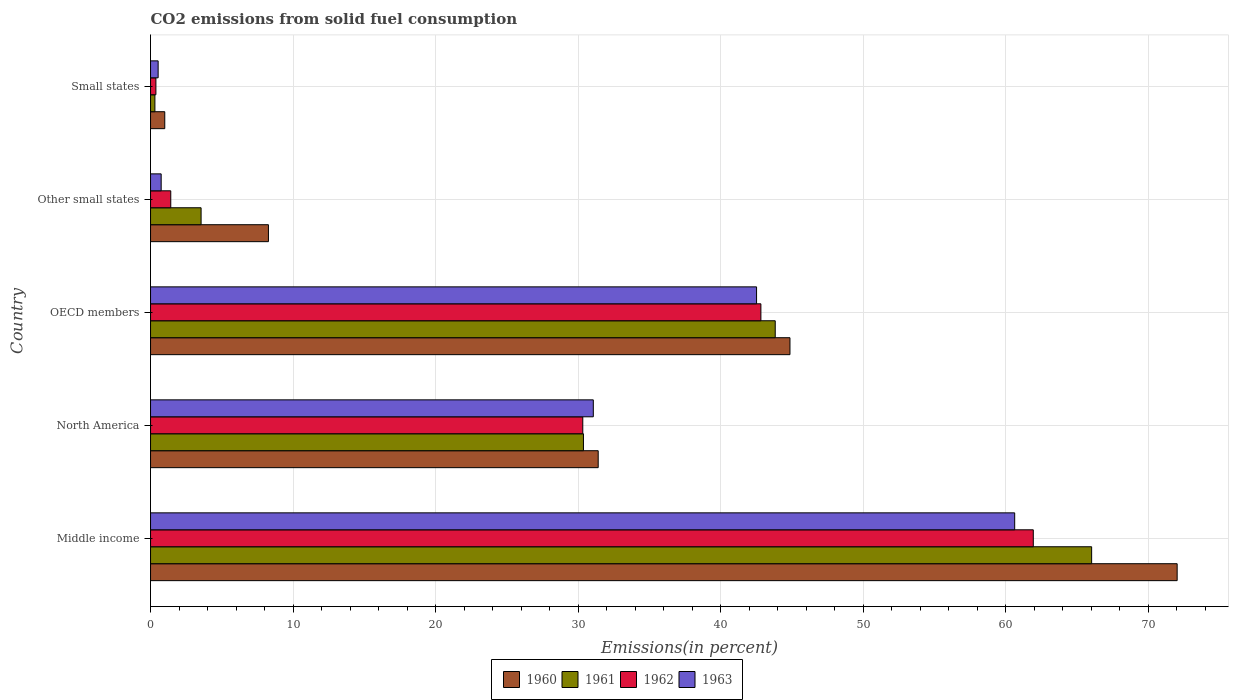Are the number of bars per tick equal to the number of legend labels?
Your response must be concise. Yes. How many bars are there on the 1st tick from the bottom?
Give a very brief answer. 4. What is the label of the 2nd group of bars from the top?
Provide a succinct answer. Other small states. What is the total CO2 emitted in 1962 in OECD members?
Provide a succinct answer. 42.82. Across all countries, what is the maximum total CO2 emitted in 1961?
Offer a terse response. 66.02. Across all countries, what is the minimum total CO2 emitted in 1960?
Offer a terse response. 1. In which country was the total CO2 emitted in 1961 maximum?
Give a very brief answer. Middle income. In which country was the total CO2 emitted in 1961 minimum?
Ensure brevity in your answer.  Small states. What is the total total CO2 emitted in 1960 in the graph?
Your answer should be compact. 157.54. What is the difference between the total CO2 emitted in 1960 in OECD members and that in Other small states?
Your response must be concise. 36.58. What is the difference between the total CO2 emitted in 1962 in Other small states and the total CO2 emitted in 1961 in Small states?
Provide a short and direct response. 1.11. What is the average total CO2 emitted in 1963 per country?
Provide a succinct answer. 27.09. What is the difference between the total CO2 emitted in 1961 and total CO2 emitted in 1963 in Small states?
Your answer should be compact. -0.23. What is the ratio of the total CO2 emitted in 1960 in Other small states to that in Small states?
Your answer should be very brief. 8.28. Is the difference between the total CO2 emitted in 1961 in North America and Other small states greater than the difference between the total CO2 emitted in 1963 in North America and Other small states?
Your response must be concise. No. What is the difference between the highest and the second highest total CO2 emitted in 1962?
Ensure brevity in your answer.  19.11. What is the difference between the highest and the lowest total CO2 emitted in 1962?
Your answer should be compact. 61.55. Is the sum of the total CO2 emitted in 1963 in Middle income and Small states greater than the maximum total CO2 emitted in 1961 across all countries?
Give a very brief answer. No. Is it the case that in every country, the sum of the total CO2 emitted in 1962 and total CO2 emitted in 1961 is greater than the sum of total CO2 emitted in 1960 and total CO2 emitted in 1963?
Make the answer very short. No. What does the 2nd bar from the top in North America represents?
Provide a succinct answer. 1962. What does the 2nd bar from the bottom in Small states represents?
Give a very brief answer. 1961. Is it the case that in every country, the sum of the total CO2 emitted in 1961 and total CO2 emitted in 1963 is greater than the total CO2 emitted in 1960?
Ensure brevity in your answer.  No. How many bars are there?
Offer a very short reply. 20. Are all the bars in the graph horizontal?
Make the answer very short. Yes. Are the values on the major ticks of X-axis written in scientific E-notation?
Provide a short and direct response. No. Does the graph contain grids?
Your response must be concise. Yes. How many legend labels are there?
Make the answer very short. 4. How are the legend labels stacked?
Offer a terse response. Horizontal. What is the title of the graph?
Offer a terse response. CO2 emissions from solid fuel consumption. What is the label or title of the X-axis?
Give a very brief answer. Emissions(in percent). What is the label or title of the Y-axis?
Your answer should be very brief. Country. What is the Emissions(in percent) of 1960 in Middle income?
Provide a succinct answer. 72.02. What is the Emissions(in percent) of 1961 in Middle income?
Your response must be concise. 66.02. What is the Emissions(in percent) in 1962 in Middle income?
Offer a terse response. 61.92. What is the Emissions(in percent) in 1963 in Middle income?
Your answer should be very brief. 60.62. What is the Emissions(in percent) in 1960 in North America?
Your response must be concise. 31.4. What is the Emissions(in percent) in 1961 in North America?
Provide a short and direct response. 30.37. What is the Emissions(in percent) in 1962 in North America?
Your answer should be very brief. 30.32. What is the Emissions(in percent) in 1963 in North America?
Your response must be concise. 31.06. What is the Emissions(in percent) in 1960 in OECD members?
Keep it short and to the point. 44.86. What is the Emissions(in percent) of 1961 in OECD members?
Your response must be concise. 43.82. What is the Emissions(in percent) in 1962 in OECD members?
Provide a short and direct response. 42.82. What is the Emissions(in percent) in 1963 in OECD members?
Keep it short and to the point. 42.51. What is the Emissions(in percent) of 1960 in Other small states?
Your answer should be very brief. 8.27. What is the Emissions(in percent) in 1961 in Other small states?
Offer a very short reply. 3.55. What is the Emissions(in percent) of 1962 in Other small states?
Your answer should be compact. 1.42. What is the Emissions(in percent) of 1963 in Other small states?
Keep it short and to the point. 0.75. What is the Emissions(in percent) of 1960 in Small states?
Offer a terse response. 1. What is the Emissions(in percent) in 1961 in Small states?
Give a very brief answer. 0.31. What is the Emissions(in percent) in 1962 in Small states?
Your answer should be very brief. 0.38. What is the Emissions(in percent) in 1963 in Small states?
Ensure brevity in your answer.  0.53. Across all countries, what is the maximum Emissions(in percent) of 1960?
Your answer should be very brief. 72.02. Across all countries, what is the maximum Emissions(in percent) of 1961?
Your answer should be compact. 66.02. Across all countries, what is the maximum Emissions(in percent) of 1962?
Make the answer very short. 61.92. Across all countries, what is the maximum Emissions(in percent) in 1963?
Make the answer very short. 60.62. Across all countries, what is the minimum Emissions(in percent) of 1960?
Make the answer very short. 1. Across all countries, what is the minimum Emissions(in percent) of 1961?
Make the answer very short. 0.31. Across all countries, what is the minimum Emissions(in percent) of 1962?
Ensure brevity in your answer.  0.38. Across all countries, what is the minimum Emissions(in percent) of 1963?
Provide a succinct answer. 0.53. What is the total Emissions(in percent) of 1960 in the graph?
Provide a succinct answer. 157.54. What is the total Emissions(in percent) of 1961 in the graph?
Make the answer very short. 144.06. What is the total Emissions(in percent) in 1962 in the graph?
Your answer should be compact. 136.86. What is the total Emissions(in percent) in 1963 in the graph?
Offer a terse response. 135.47. What is the difference between the Emissions(in percent) in 1960 in Middle income and that in North America?
Offer a very short reply. 40.61. What is the difference between the Emissions(in percent) in 1961 in Middle income and that in North America?
Keep it short and to the point. 35.65. What is the difference between the Emissions(in percent) in 1962 in Middle income and that in North America?
Give a very brief answer. 31.6. What is the difference between the Emissions(in percent) in 1963 in Middle income and that in North America?
Make the answer very short. 29.56. What is the difference between the Emissions(in percent) in 1960 in Middle income and that in OECD members?
Your answer should be compact. 27.16. What is the difference between the Emissions(in percent) in 1961 in Middle income and that in OECD members?
Provide a succinct answer. 22.2. What is the difference between the Emissions(in percent) in 1962 in Middle income and that in OECD members?
Offer a terse response. 19.11. What is the difference between the Emissions(in percent) in 1963 in Middle income and that in OECD members?
Offer a terse response. 18.11. What is the difference between the Emissions(in percent) in 1960 in Middle income and that in Other small states?
Your answer should be very brief. 63.75. What is the difference between the Emissions(in percent) of 1961 in Middle income and that in Other small states?
Your answer should be very brief. 62.47. What is the difference between the Emissions(in percent) in 1962 in Middle income and that in Other small states?
Give a very brief answer. 60.51. What is the difference between the Emissions(in percent) in 1963 in Middle income and that in Other small states?
Your answer should be compact. 59.87. What is the difference between the Emissions(in percent) in 1960 in Middle income and that in Small states?
Give a very brief answer. 71.02. What is the difference between the Emissions(in percent) in 1961 in Middle income and that in Small states?
Keep it short and to the point. 65.71. What is the difference between the Emissions(in percent) of 1962 in Middle income and that in Small states?
Your answer should be compact. 61.55. What is the difference between the Emissions(in percent) in 1963 in Middle income and that in Small states?
Offer a terse response. 60.09. What is the difference between the Emissions(in percent) of 1960 in North America and that in OECD members?
Your answer should be very brief. -13.45. What is the difference between the Emissions(in percent) in 1961 in North America and that in OECD members?
Offer a terse response. -13.45. What is the difference between the Emissions(in percent) in 1962 in North America and that in OECD members?
Offer a very short reply. -12.49. What is the difference between the Emissions(in percent) in 1963 in North America and that in OECD members?
Keep it short and to the point. -11.45. What is the difference between the Emissions(in percent) of 1960 in North America and that in Other small states?
Your answer should be very brief. 23.13. What is the difference between the Emissions(in percent) of 1961 in North America and that in Other small states?
Your answer should be compact. 26.82. What is the difference between the Emissions(in percent) in 1962 in North America and that in Other small states?
Provide a short and direct response. 28.9. What is the difference between the Emissions(in percent) of 1963 in North America and that in Other small states?
Give a very brief answer. 30.31. What is the difference between the Emissions(in percent) of 1960 in North America and that in Small states?
Your response must be concise. 30.4. What is the difference between the Emissions(in percent) of 1961 in North America and that in Small states?
Offer a very short reply. 30.06. What is the difference between the Emissions(in percent) in 1962 in North America and that in Small states?
Provide a short and direct response. 29.95. What is the difference between the Emissions(in percent) in 1963 in North America and that in Small states?
Offer a very short reply. 30.53. What is the difference between the Emissions(in percent) in 1960 in OECD members and that in Other small states?
Your response must be concise. 36.58. What is the difference between the Emissions(in percent) in 1961 in OECD members and that in Other small states?
Your response must be concise. 40.28. What is the difference between the Emissions(in percent) of 1962 in OECD members and that in Other small states?
Offer a very short reply. 41.4. What is the difference between the Emissions(in percent) of 1963 in OECD members and that in Other small states?
Your response must be concise. 41.77. What is the difference between the Emissions(in percent) in 1960 in OECD members and that in Small states?
Keep it short and to the point. 43.86. What is the difference between the Emissions(in percent) in 1961 in OECD members and that in Small states?
Your answer should be very brief. 43.52. What is the difference between the Emissions(in percent) in 1962 in OECD members and that in Small states?
Offer a very short reply. 42.44. What is the difference between the Emissions(in percent) in 1963 in OECD members and that in Small states?
Ensure brevity in your answer.  41.98. What is the difference between the Emissions(in percent) of 1960 in Other small states and that in Small states?
Your response must be concise. 7.27. What is the difference between the Emissions(in percent) in 1961 in Other small states and that in Small states?
Your answer should be very brief. 3.24. What is the difference between the Emissions(in percent) in 1962 in Other small states and that in Small states?
Your response must be concise. 1.04. What is the difference between the Emissions(in percent) in 1963 in Other small states and that in Small states?
Make the answer very short. 0.21. What is the difference between the Emissions(in percent) of 1960 in Middle income and the Emissions(in percent) of 1961 in North America?
Your response must be concise. 41.65. What is the difference between the Emissions(in percent) in 1960 in Middle income and the Emissions(in percent) in 1962 in North America?
Give a very brief answer. 41.7. What is the difference between the Emissions(in percent) of 1960 in Middle income and the Emissions(in percent) of 1963 in North America?
Your answer should be very brief. 40.96. What is the difference between the Emissions(in percent) in 1961 in Middle income and the Emissions(in percent) in 1962 in North America?
Your response must be concise. 35.7. What is the difference between the Emissions(in percent) in 1961 in Middle income and the Emissions(in percent) in 1963 in North America?
Your answer should be very brief. 34.96. What is the difference between the Emissions(in percent) of 1962 in Middle income and the Emissions(in percent) of 1963 in North America?
Your response must be concise. 30.86. What is the difference between the Emissions(in percent) of 1960 in Middle income and the Emissions(in percent) of 1961 in OECD members?
Offer a terse response. 28.2. What is the difference between the Emissions(in percent) in 1960 in Middle income and the Emissions(in percent) in 1962 in OECD members?
Provide a succinct answer. 29.2. What is the difference between the Emissions(in percent) in 1960 in Middle income and the Emissions(in percent) in 1963 in OECD members?
Give a very brief answer. 29.51. What is the difference between the Emissions(in percent) in 1961 in Middle income and the Emissions(in percent) in 1962 in OECD members?
Your response must be concise. 23.2. What is the difference between the Emissions(in percent) of 1961 in Middle income and the Emissions(in percent) of 1963 in OECD members?
Your answer should be very brief. 23.51. What is the difference between the Emissions(in percent) in 1962 in Middle income and the Emissions(in percent) in 1963 in OECD members?
Ensure brevity in your answer.  19.41. What is the difference between the Emissions(in percent) in 1960 in Middle income and the Emissions(in percent) in 1961 in Other small states?
Make the answer very short. 68.47. What is the difference between the Emissions(in percent) in 1960 in Middle income and the Emissions(in percent) in 1962 in Other small states?
Offer a terse response. 70.6. What is the difference between the Emissions(in percent) of 1960 in Middle income and the Emissions(in percent) of 1963 in Other small states?
Offer a very short reply. 71.27. What is the difference between the Emissions(in percent) of 1961 in Middle income and the Emissions(in percent) of 1962 in Other small states?
Ensure brevity in your answer.  64.6. What is the difference between the Emissions(in percent) in 1961 in Middle income and the Emissions(in percent) in 1963 in Other small states?
Your response must be concise. 65.27. What is the difference between the Emissions(in percent) of 1962 in Middle income and the Emissions(in percent) of 1963 in Other small states?
Keep it short and to the point. 61.18. What is the difference between the Emissions(in percent) of 1960 in Middle income and the Emissions(in percent) of 1961 in Small states?
Provide a succinct answer. 71.71. What is the difference between the Emissions(in percent) in 1960 in Middle income and the Emissions(in percent) in 1962 in Small states?
Your answer should be compact. 71.64. What is the difference between the Emissions(in percent) in 1960 in Middle income and the Emissions(in percent) in 1963 in Small states?
Give a very brief answer. 71.48. What is the difference between the Emissions(in percent) of 1961 in Middle income and the Emissions(in percent) of 1962 in Small states?
Provide a short and direct response. 65.64. What is the difference between the Emissions(in percent) of 1961 in Middle income and the Emissions(in percent) of 1963 in Small states?
Offer a very short reply. 65.48. What is the difference between the Emissions(in percent) in 1962 in Middle income and the Emissions(in percent) in 1963 in Small states?
Your response must be concise. 61.39. What is the difference between the Emissions(in percent) of 1960 in North America and the Emissions(in percent) of 1961 in OECD members?
Offer a very short reply. -12.42. What is the difference between the Emissions(in percent) of 1960 in North America and the Emissions(in percent) of 1962 in OECD members?
Make the answer very short. -11.41. What is the difference between the Emissions(in percent) of 1960 in North America and the Emissions(in percent) of 1963 in OECD members?
Offer a very short reply. -11.11. What is the difference between the Emissions(in percent) in 1961 in North America and the Emissions(in percent) in 1962 in OECD members?
Make the answer very short. -12.45. What is the difference between the Emissions(in percent) in 1961 in North America and the Emissions(in percent) in 1963 in OECD members?
Keep it short and to the point. -12.14. What is the difference between the Emissions(in percent) of 1962 in North America and the Emissions(in percent) of 1963 in OECD members?
Your answer should be very brief. -12.19. What is the difference between the Emissions(in percent) in 1960 in North America and the Emissions(in percent) in 1961 in Other small states?
Ensure brevity in your answer.  27.86. What is the difference between the Emissions(in percent) of 1960 in North America and the Emissions(in percent) of 1962 in Other small states?
Your answer should be very brief. 29.98. What is the difference between the Emissions(in percent) in 1960 in North America and the Emissions(in percent) in 1963 in Other small states?
Give a very brief answer. 30.66. What is the difference between the Emissions(in percent) in 1961 in North America and the Emissions(in percent) in 1962 in Other small states?
Keep it short and to the point. 28.95. What is the difference between the Emissions(in percent) in 1961 in North America and the Emissions(in percent) in 1963 in Other small states?
Your answer should be compact. 29.62. What is the difference between the Emissions(in percent) in 1962 in North America and the Emissions(in percent) in 1963 in Other small states?
Your response must be concise. 29.58. What is the difference between the Emissions(in percent) in 1960 in North America and the Emissions(in percent) in 1961 in Small states?
Provide a short and direct response. 31.1. What is the difference between the Emissions(in percent) in 1960 in North America and the Emissions(in percent) in 1962 in Small states?
Make the answer very short. 31.03. What is the difference between the Emissions(in percent) of 1960 in North America and the Emissions(in percent) of 1963 in Small states?
Your response must be concise. 30.87. What is the difference between the Emissions(in percent) of 1961 in North America and the Emissions(in percent) of 1962 in Small states?
Make the answer very short. 29.99. What is the difference between the Emissions(in percent) of 1961 in North America and the Emissions(in percent) of 1963 in Small states?
Your answer should be compact. 29.84. What is the difference between the Emissions(in percent) of 1962 in North America and the Emissions(in percent) of 1963 in Small states?
Your answer should be compact. 29.79. What is the difference between the Emissions(in percent) of 1960 in OECD members and the Emissions(in percent) of 1961 in Other small states?
Provide a succinct answer. 41.31. What is the difference between the Emissions(in percent) of 1960 in OECD members and the Emissions(in percent) of 1962 in Other small states?
Give a very brief answer. 43.44. What is the difference between the Emissions(in percent) in 1960 in OECD members and the Emissions(in percent) in 1963 in Other small states?
Your response must be concise. 44.11. What is the difference between the Emissions(in percent) in 1961 in OECD members and the Emissions(in percent) in 1962 in Other small states?
Provide a short and direct response. 42.4. What is the difference between the Emissions(in percent) in 1961 in OECD members and the Emissions(in percent) in 1963 in Other small states?
Ensure brevity in your answer.  43.08. What is the difference between the Emissions(in percent) in 1962 in OECD members and the Emissions(in percent) in 1963 in Other small states?
Ensure brevity in your answer.  42.07. What is the difference between the Emissions(in percent) in 1960 in OECD members and the Emissions(in percent) in 1961 in Small states?
Your answer should be very brief. 44.55. What is the difference between the Emissions(in percent) in 1960 in OECD members and the Emissions(in percent) in 1962 in Small states?
Give a very brief answer. 44.48. What is the difference between the Emissions(in percent) in 1960 in OECD members and the Emissions(in percent) in 1963 in Small states?
Your answer should be compact. 44.32. What is the difference between the Emissions(in percent) of 1961 in OECD members and the Emissions(in percent) of 1962 in Small states?
Make the answer very short. 43.45. What is the difference between the Emissions(in percent) in 1961 in OECD members and the Emissions(in percent) in 1963 in Small states?
Your response must be concise. 43.29. What is the difference between the Emissions(in percent) of 1962 in OECD members and the Emissions(in percent) of 1963 in Small states?
Keep it short and to the point. 42.28. What is the difference between the Emissions(in percent) in 1960 in Other small states and the Emissions(in percent) in 1961 in Small states?
Give a very brief answer. 7.96. What is the difference between the Emissions(in percent) of 1960 in Other small states and the Emissions(in percent) of 1962 in Small states?
Your answer should be very brief. 7.89. What is the difference between the Emissions(in percent) in 1960 in Other small states and the Emissions(in percent) in 1963 in Small states?
Your answer should be very brief. 7.74. What is the difference between the Emissions(in percent) in 1961 in Other small states and the Emissions(in percent) in 1962 in Small states?
Your answer should be compact. 3.17. What is the difference between the Emissions(in percent) of 1961 in Other small states and the Emissions(in percent) of 1963 in Small states?
Offer a very short reply. 3.01. What is the difference between the Emissions(in percent) in 1962 in Other small states and the Emissions(in percent) in 1963 in Small states?
Give a very brief answer. 0.88. What is the average Emissions(in percent) in 1960 per country?
Your answer should be very brief. 31.51. What is the average Emissions(in percent) in 1961 per country?
Your response must be concise. 28.81. What is the average Emissions(in percent) in 1962 per country?
Offer a very short reply. 27.37. What is the average Emissions(in percent) in 1963 per country?
Offer a very short reply. 27.09. What is the difference between the Emissions(in percent) in 1960 and Emissions(in percent) in 1961 in Middle income?
Offer a very short reply. 6. What is the difference between the Emissions(in percent) in 1960 and Emissions(in percent) in 1962 in Middle income?
Your answer should be very brief. 10.09. What is the difference between the Emissions(in percent) of 1960 and Emissions(in percent) of 1963 in Middle income?
Your response must be concise. 11.4. What is the difference between the Emissions(in percent) in 1961 and Emissions(in percent) in 1962 in Middle income?
Provide a succinct answer. 4.09. What is the difference between the Emissions(in percent) in 1961 and Emissions(in percent) in 1963 in Middle income?
Your answer should be compact. 5.4. What is the difference between the Emissions(in percent) in 1962 and Emissions(in percent) in 1963 in Middle income?
Your answer should be very brief. 1.31. What is the difference between the Emissions(in percent) of 1960 and Emissions(in percent) of 1961 in North America?
Ensure brevity in your answer.  1.03. What is the difference between the Emissions(in percent) of 1960 and Emissions(in percent) of 1962 in North America?
Your response must be concise. 1.08. What is the difference between the Emissions(in percent) of 1960 and Emissions(in percent) of 1963 in North America?
Your answer should be compact. 0.34. What is the difference between the Emissions(in percent) of 1961 and Emissions(in percent) of 1962 in North America?
Ensure brevity in your answer.  0.05. What is the difference between the Emissions(in percent) in 1961 and Emissions(in percent) in 1963 in North America?
Keep it short and to the point. -0.69. What is the difference between the Emissions(in percent) in 1962 and Emissions(in percent) in 1963 in North America?
Offer a very short reply. -0.74. What is the difference between the Emissions(in percent) of 1960 and Emissions(in percent) of 1962 in OECD members?
Keep it short and to the point. 2.04. What is the difference between the Emissions(in percent) in 1960 and Emissions(in percent) in 1963 in OECD members?
Your answer should be very brief. 2.34. What is the difference between the Emissions(in percent) of 1961 and Emissions(in percent) of 1963 in OECD members?
Offer a terse response. 1.31. What is the difference between the Emissions(in percent) in 1962 and Emissions(in percent) in 1963 in OECD members?
Give a very brief answer. 0.3. What is the difference between the Emissions(in percent) in 1960 and Emissions(in percent) in 1961 in Other small states?
Give a very brief answer. 4.72. What is the difference between the Emissions(in percent) in 1960 and Emissions(in percent) in 1962 in Other small states?
Offer a very short reply. 6.85. What is the difference between the Emissions(in percent) of 1960 and Emissions(in percent) of 1963 in Other small states?
Make the answer very short. 7.52. What is the difference between the Emissions(in percent) of 1961 and Emissions(in percent) of 1962 in Other small states?
Your answer should be very brief. 2.13. What is the difference between the Emissions(in percent) in 1961 and Emissions(in percent) in 1963 in Other small states?
Your answer should be very brief. 2.8. What is the difference between the Emissions(in percent) in 1962 and Emissions(in percent) in 1963 in Other small states?
Ensure brevity in your answer.  0.67. What is the difference between the Emissions(in percent) in 1960 and Emissions(in percent) in 1961 in Small states?
Your answer should be very brief. 0.69. What is the difference between the Emissions(in percent) of 1960 and Emissions(in percent) of 1962 in Small states?
Make the answer very short. 0.62. What is the difference between the Emissions(in percent) in 1960 and Emissions(in percent) in 1963 in Small states?
Your response must be concise. 0.46. What is the difference between the Emissions(in percent) of 1961 and Emissions(in percent) of 1962 in Small states?
Offer a terse response. -0.07. What is the difference between the Emissions(in percent) in 1961 and Emissions(in percent) in 1963 in Small states?
Make the answer very short. -0.23. What is the difference between the Emissions(in percent) in 1962 and Emissions(in percent) in 1963 in Small states?
Ensure brevity in your answer.  -0.16. What is the ratio of the Emissions(in percent) in 1960 in Middle income to that in North America?
Your response must be concise. 2.29. What is the ratio of the Emissions(in percent) of 1961 in Middle income to that in North America?
Make the answer very short. 2.17. What is the ratio of the Emissions(in percent) of 1962 in Middle income to that in North America?
Offer a very short reply. 2.04. What is the ratio of the Emissions(in percent) in 1963 in Middle income to that in North America?
Keep it short and to the point. 1.95. What is the ratio of the Emissions(in percent) of 1960 in Middle income to that in OECD members?
Keep it short and to the point. 1.61. What is the ratio of the Emissions(in percent) in 1961 in Middle income to that in OECD members?
Give a very brief answer. 1.51. What is the ratio of the Emissions(in percent) of 1962 in Middle income to that in OECD members?
Provide a succinct answer. 1.45. What is the ratio of the Emissions(in percent) of 1963 in Middle income to that in OECD members?
Offer a terse response. 1.43. What is the ratio of the Emissions(in percent) of 1960 in Middle income to that in Other small states?
Offer a very short reply. 8.71. What is the ratio of the Emissions(in percent) in 1961 in Middle income to that in Other small states?
Ensure brevity in your answer.  18.62. What is the ratio of the Emissions(in percent) in 1962 in Middle income to that in Other small states?
Provide a succinct answer. 43.66. What is the ratio of the Emissions(in percent) in 1963 in Middle income to that in Other small states?
Offer a terse response. 81.23. What is the ratio of the Emissions(in percent) of 1960 in Middle income to that in Small states?
Your answer should be very brief. 72.14. What is the ratio of the Emissions(in percent) in 1961 in Middle income to that in Small states?
Keep it short and to the point. 215.88. What is the ratio of the Emissions(in percent) in 1962 in Middle income to that in Small states?
Provide a short and direct response. 164.53. What is the ratio of the Emissions(in percent) of 1963 in Middle income to that in Small states?
Your response must be concise. 113.6. What is the ratio of the Emissions(in percent) of 1960 in North America to that in OECD members?
Your answer should be very brief. 0.7. What is the ratio of the Emissions(in percent) in 1961 in North America to that in OECD members?
Give a very brief answer. 0.69. What is the ratio of the Emissions(in percent) in 1962 in North America to that in OECD members?
Ensure brevity in your answer.  0.71. What is the ratio of the Emissions(in percent) of 1963 in North America to that in OECD members?
Provide a short and direct response. 0.73. What is the ratio of the Emissions(in percent) of 1960 in North America to that in Other small states?
Ensure brevity in your answer.  3.8. What is the ratio of the Emissions(in percent) in 1961 in North America to that in Other small states?
Make the answer very short. 8.56. What is the ratio of the Emissions(in percent) in 1962 in North America to that in Other small states?
Give a very brief answer. 21.38. What is the ratio of the Emissions(in percent) of 1963 in North America to that in Other small states?
Make the answer very short. 41.62. What is the ratio of the Emissions(in percent) of 1960 in North America to that in Small states?
Offer a terse response. 31.46. What is the ratio of the Emissions(in percent) of 1961 in North America to that in Small states?
Keep it short and to the point. 99.31. What is the ratio of the Emissions(in percent) of 1962 in North America to that in Small states?
Provide a short and direct response. 80.56. What is the ratio of the Emissions(in percent) in 1963 in North America to that in Small states?
Provide a succinct answer. 58.21. What is the ratio of the Emissions(in percent) in 1960 in OECD members to that in Other small states?
Ensure brevity in your answer.  5.42. What is the ratio of the Emissions(in percent) of 1961 in OECD members to that in Other small states?
Your response must be concise. 12.36. What is the ratio of the Emissions(in percent) of 1962 in OECD members to that in Other small states?
Provide a succinct answer. 30.19. What is the ratio of the Emissions(in percent) in 1963 in OECD members to that in Other small states?
Your answer should be very brief. 56.97. What is the ratio of the Emissions(in percent) of 1960 in OECD members to that in Small states?
Offer a terse response. 44.93. What is the ratio of the Emissions(in percent) in 1961 in OECD members to that in Small states?
Your answer should be very brief. 143.3. What is the ratio of the Emissions(in percent) in 1962 in OECD members to that in Small states?
Provide a succinct answer. 113.76. What is the ratio of the Emissions(in percent) in 1963 in OECD members to that in Small states?
Give a very brief answer. 79.67. What is the ratio of the Emissions(in percent) in 1960 in Other small states to that in Small states?
Make the answer very short. 8.28. What is the ratio of the Emissions(in percent) in 1961 in Other small states to that in Small states?
Give a very brief answer. 11.6. What is the ratio of the Emissions(in percent) in 1962 in Other small states to that in Small states?
Provide a short and direct response. 3.77. What is the ratio of the Emissions(in percent) in 1963 in Other small states to that in Small states?
Keep it short and to the point. 1.4. What is the difference between the highest and the second highest Emissions(in percent) of 1960?
Give a very brief answer. 27.16. What is the difference between the highest and the second highest Emissions(in percent) in 1961?
Your response must be concise. 22.2. What is the difference between the highest and the second highest Emissions(in percent) in 1962?
Your answer should be compact. 19.11. What is the difference between the highest and the second highest Emissions(in percent) in 1963?
Your answer should be compact. 18.11. What is the difference between the highest and the lowest Emissions(in percent) of 1960?
Make the answer very short. 71.02. What is the difference between the highest and the lowest Emissions(in percent) in 1961?
Ensure brevity in your answer.  65.71. What is the difference between the highest and the lowest Emissions(in percent) in 1962?
Your response must be concise. 61.55. What is the difference between the highest and the lowest Emissions(in percent) of 1963?
Offer a terse response. 60.09. 